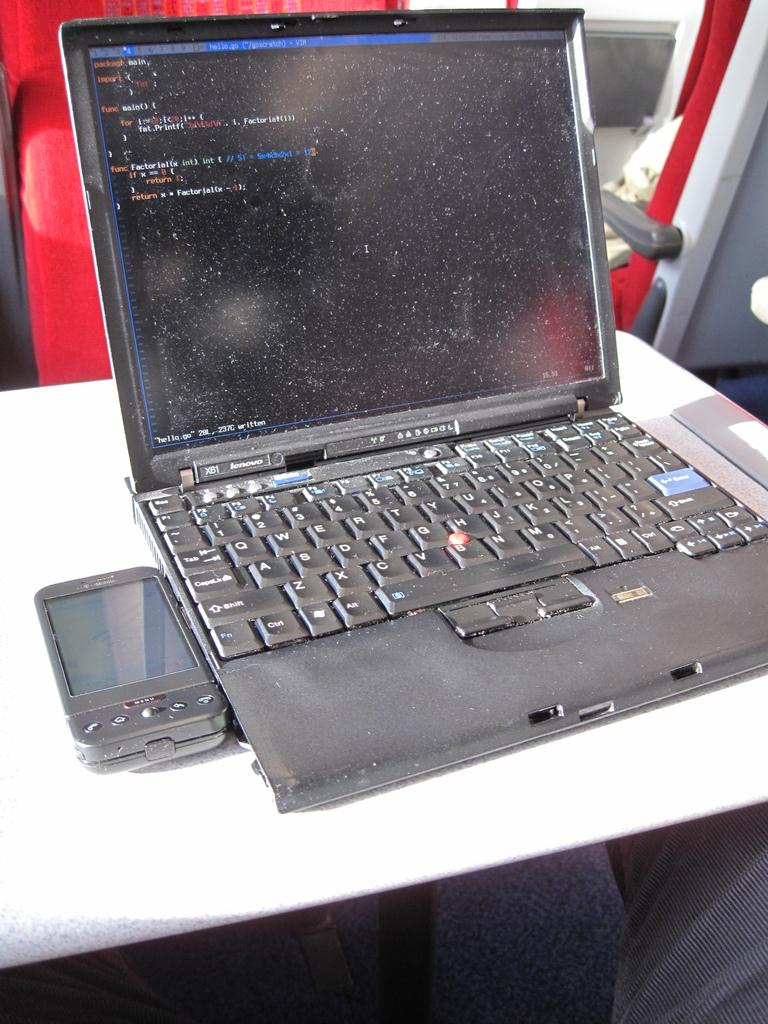<image>
Write a terse but informative summary of the picture. A dirty looking laptop with the Enter key being blue. 